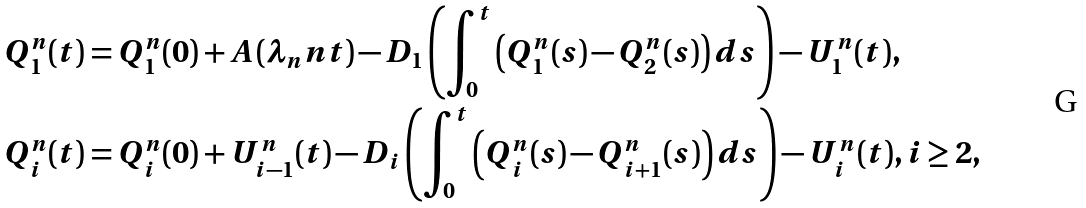<formula> <loc_0><loc_0><loc_500><loc_500>Q ^ { n } _ { 1 } ( t ) & = Q ^ { n } _ { 1 } ( 0 ) + A \left ( \lambda _ { n } n t \right ) - D _ { 1 } \left ( \int _ { 0 } ^ { t } \left ( Q ^ { n } _ { 1 } ( s ) - Q ^ { n } _ { 2 } ( s ) \right ) d s \right ) - U ^ { n } _ { 1 } ( t ) , \\ Q ^ { n } _ { i } ( t ) & = Q ^ { n } _ { i } ( 0 ) + U ^ { n } _ { i - 1 } ( t ) - D _ { i } \left ( \int _ { 0 } ^ { t } \left ( Q ^ { n } _ { i } ( s ) - Q ^ { n } _ { i + 1 } ( s ) \right ) d s \right ) - U ^ { n } _ { i } ( t ) , i \geq 2 ,</formula> 